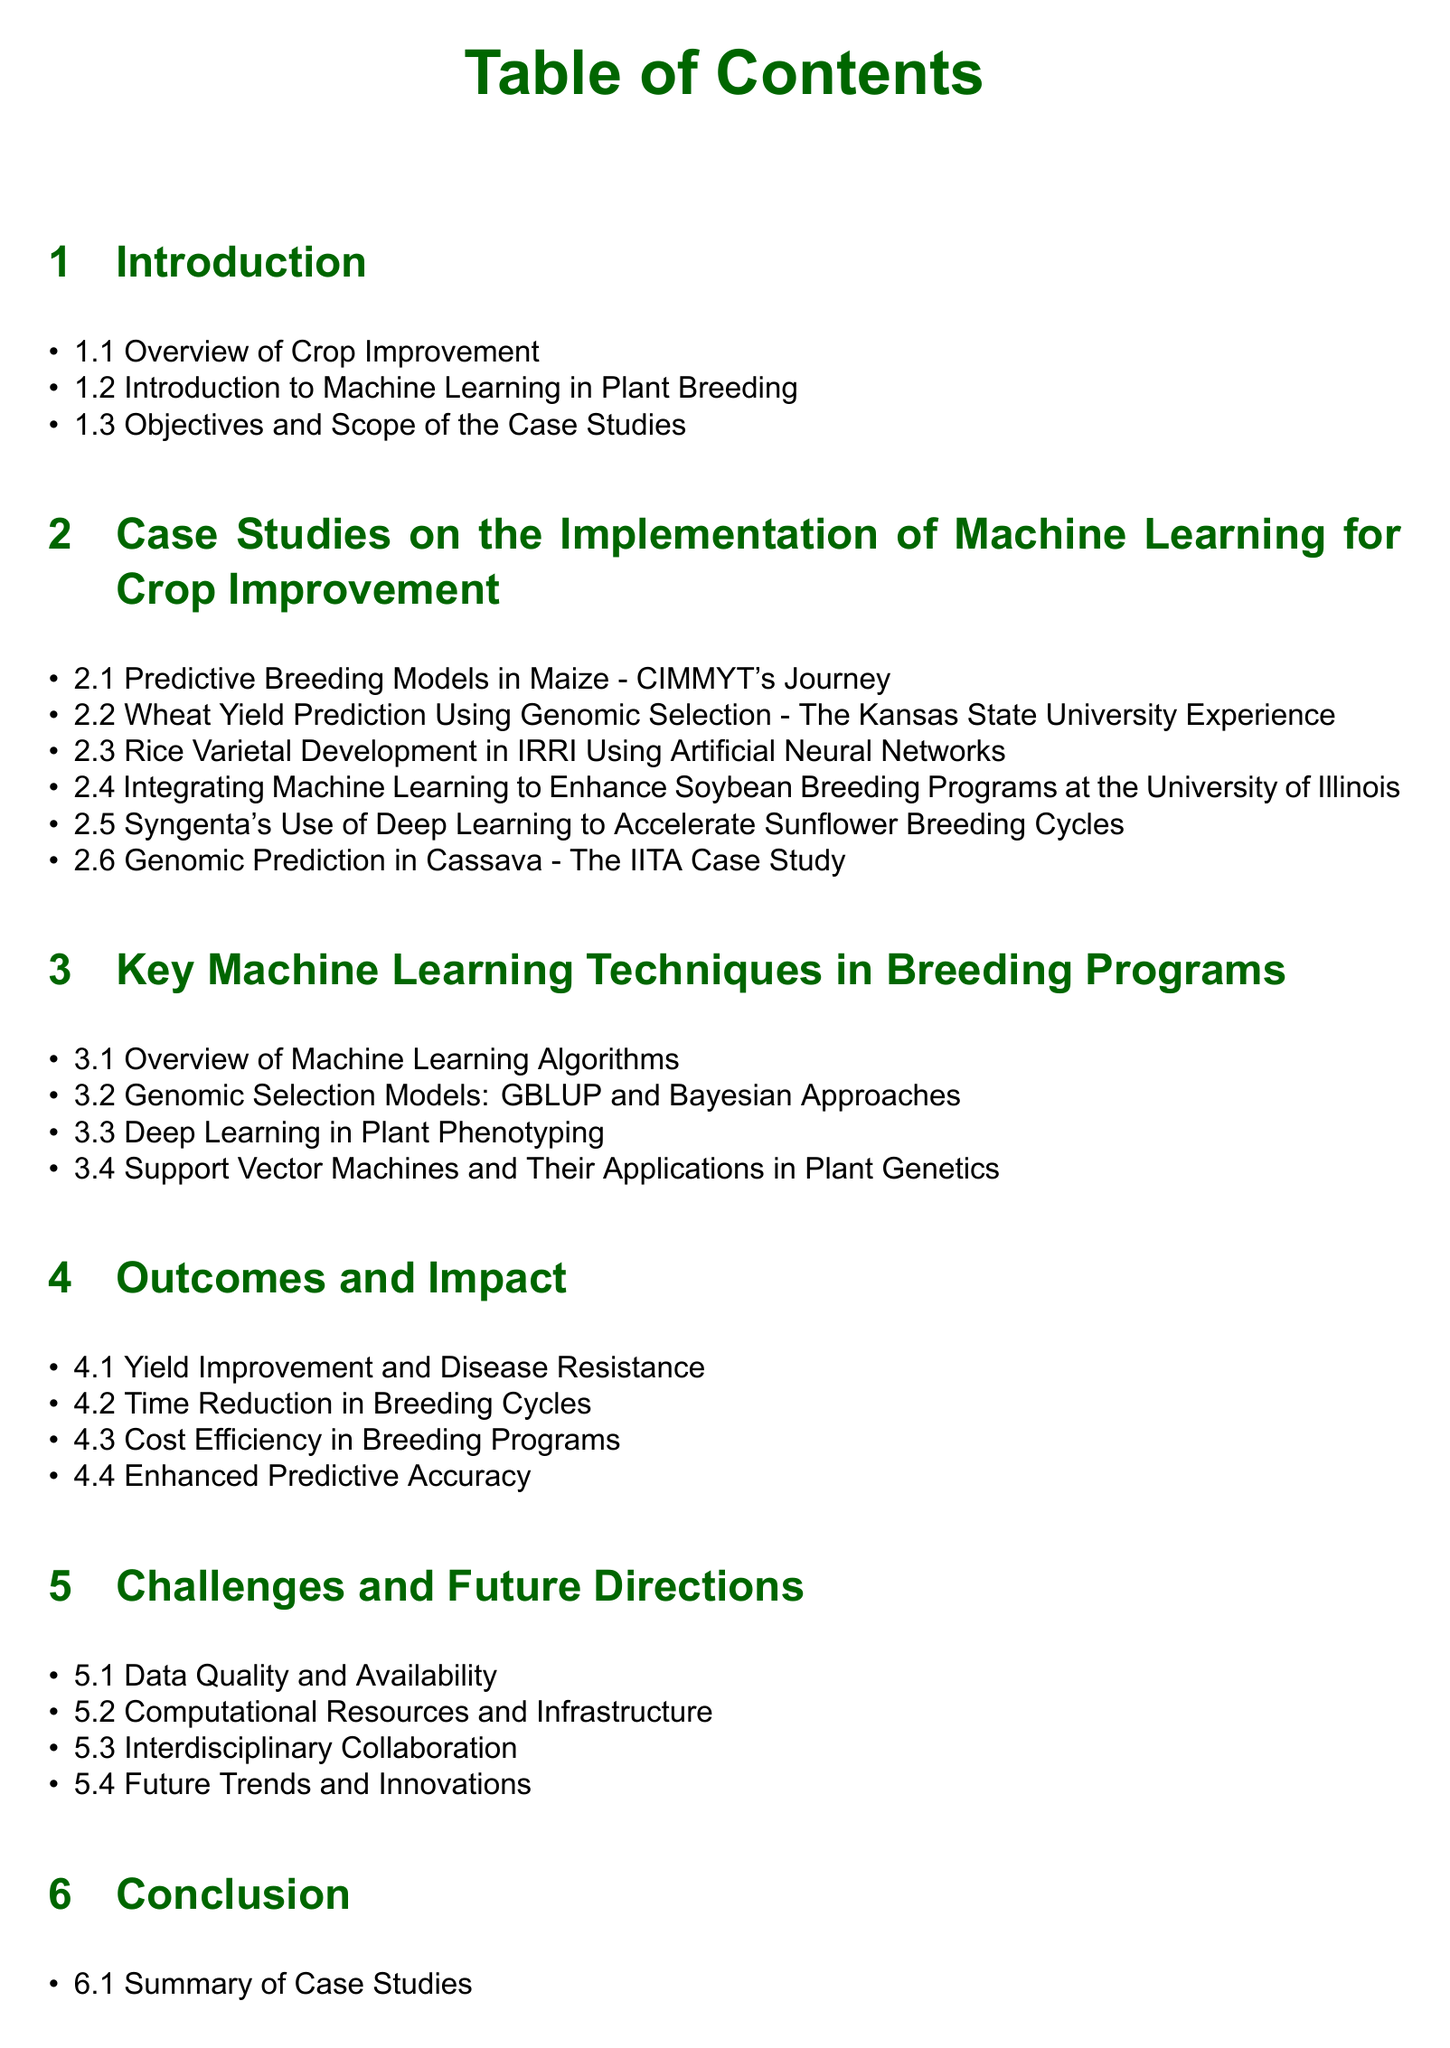What is the first case study listed? The first case study in the section is Predictive Breeding Models in Maize - CIMMYT's Journey.
Answer: Predictive Breeding Models in Maize - CIMMYT's Journey How many case studies are presented in section 2? The document lists six case studies under section 2.
Answer: 6 What machine learning technique is highlighted in 2.3? The technique highlighted in section 2.3 is Artificial Neural Networks.
Answer: Artificial Neural Networks Which institution implemented геномic selection for wheat? The Kansas State University conducted the wheat yield prediction study using genomic selection.
Answer: Kansas State University What is the main focus of section 5? Section 5 discusses challenges and future directions related to machine learning in breeding programs.
Answer: Challenges and Future Directions What section comes after the case studies? The section that follows the case studies is titled Key Machine Learning Techniques in Breeding Programs.
Answer: Key Machine Learning Techniques in Breeding Programs 